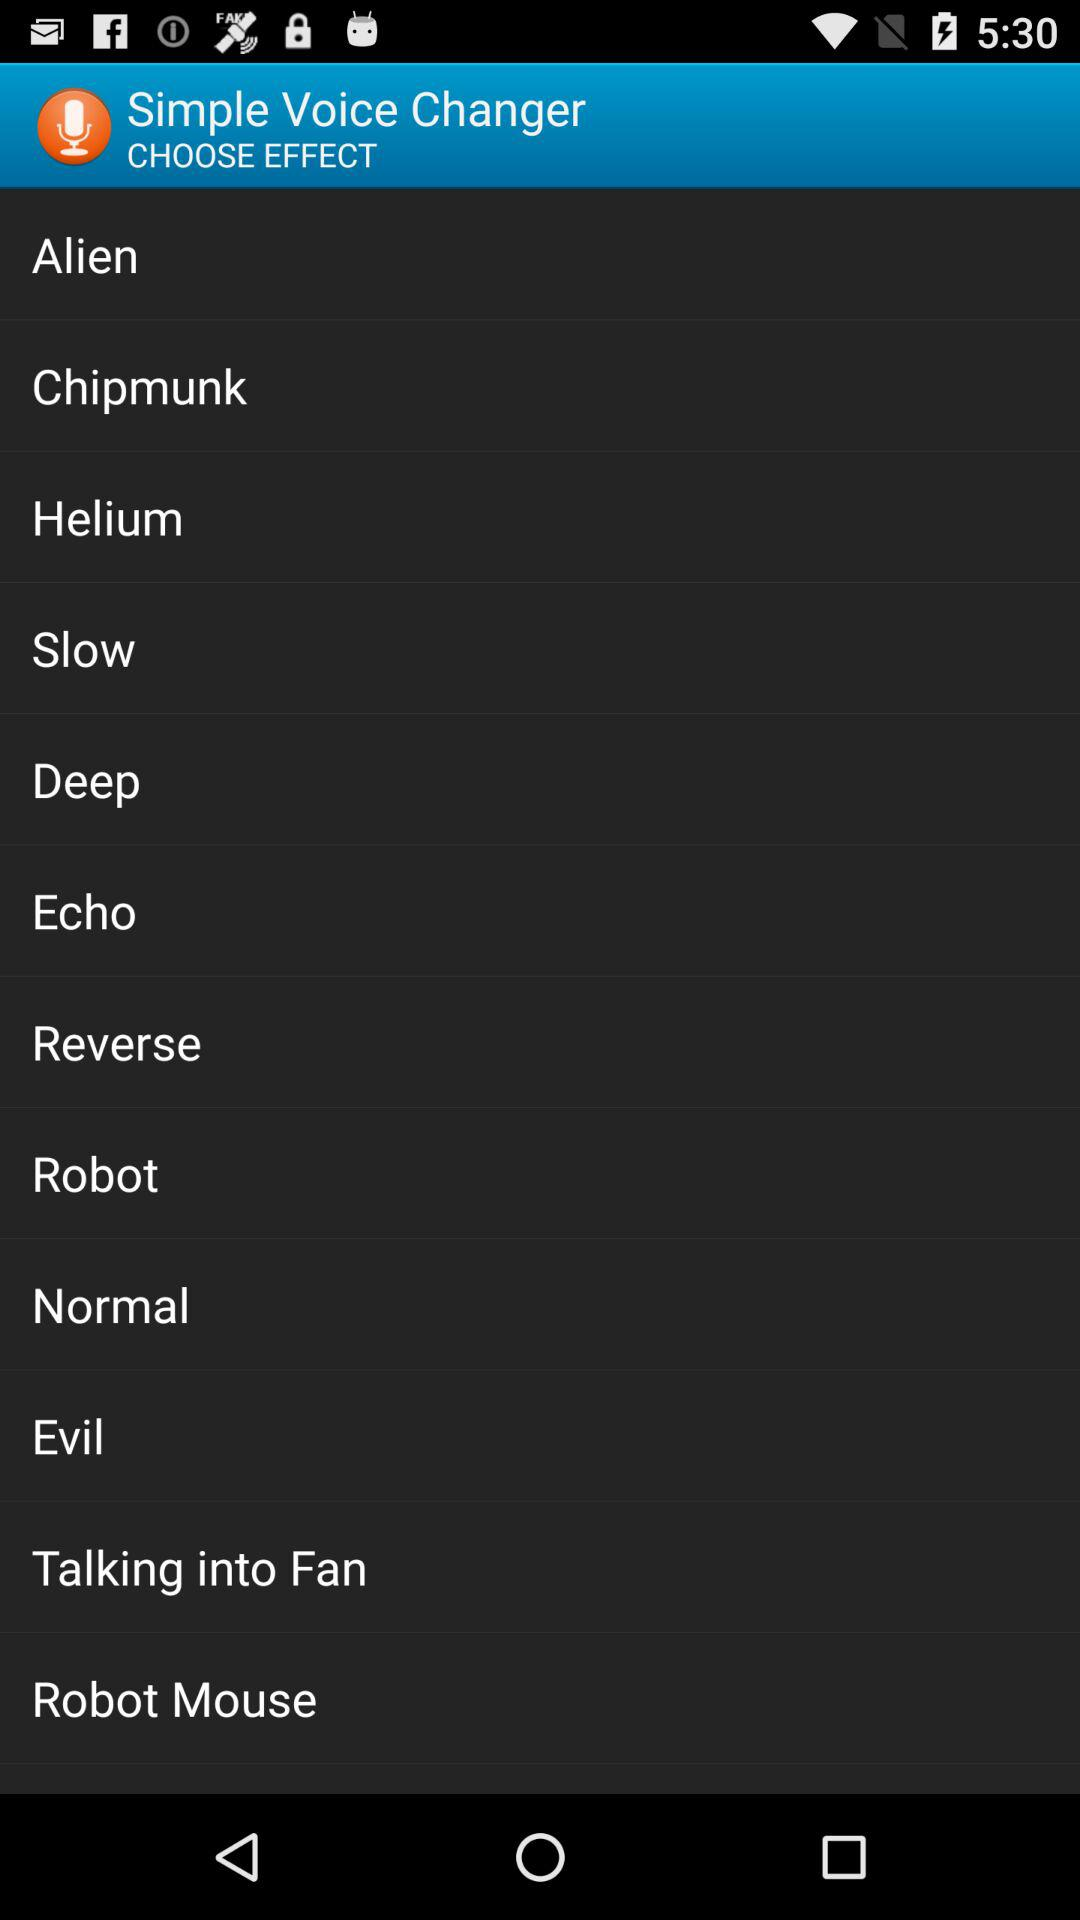What is the name of the application? The name of the application is "Simple Voice Changer". 